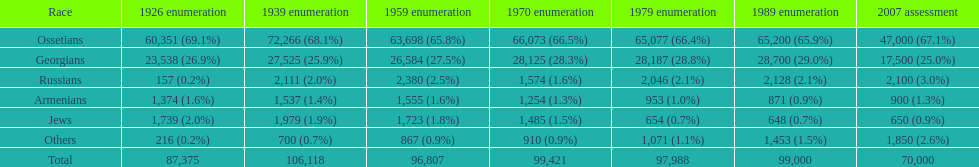What ethnicity is at the top? Ossetians. 